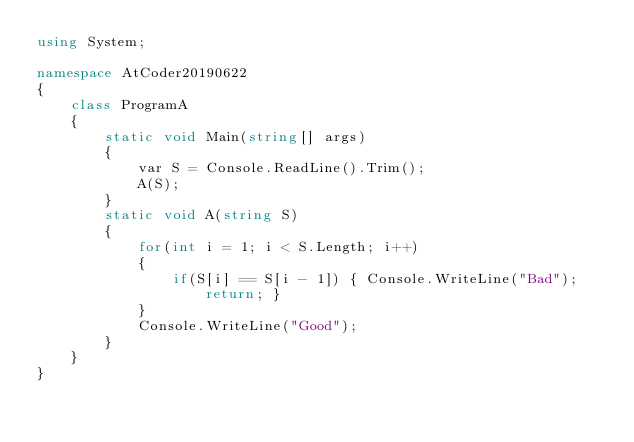Convert code to text. <code><loc_0><loc_0><loc_500><loc_500><_C#_>using System;

namespace AtCoder20190622
{
	class ProgramA
	{
		static void Main(string[] args)
		{
			var S = Console.ReadLine().Trim();
			A(S);
		}
		static void A(string S)
		{
			for(int i = 1; i < S.Length; i++)
			{
				if(S[i] == S[i - 1]) { Console.WriteLine("Bad"); return; }
			}
			Console.WriteLine("Good");
		}
	}
}
</code> 